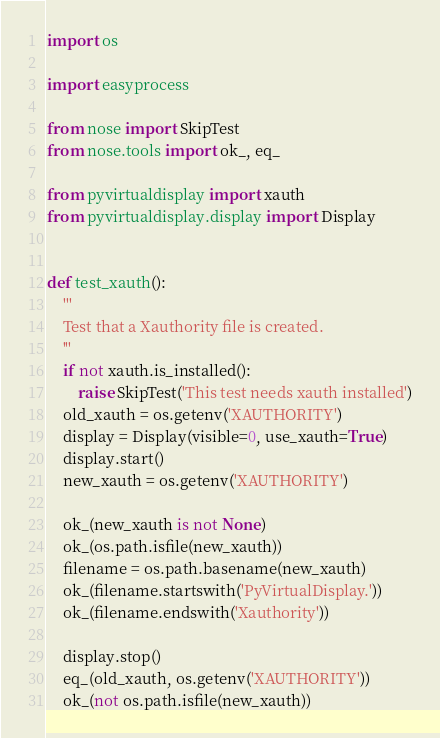<code> <loc_0><loc_0><loc_500><loc_500><_Python_>import os

import easyprocess

from nose import SkipTest
from nose.tools import ok_, eq_

from pyvirtualdisplay import xauth
from pyvirtualdisplay.display import Display


def test_xauth():
    '''
    Test that a Xauthority file is created.
    '''
    if not xauth.is_installed():
        raise SkipTest('This test needs xauth installed')
    old_xauth = os.getenv('XAUTHORITY')
    display = Display(visible=0, use_xauth=True)
    display.start()
    new_xauth = os.getenv('XAUTHORITY')

    ok_(new_xauth is not None)
    ok_(os.path.isfile(new_xauth))
    filename = os.path.basename(new_xauth)
    ok_(filename.startswith('PyVirtualDisplay.'))
    ok_(filename.endswith('Xauthority'))

    display.stop()
    eq_(old_xauth, os.getenv('XAUTHORITY'))
    ok_(not os.path.isfile(new_xauth))
</code> 